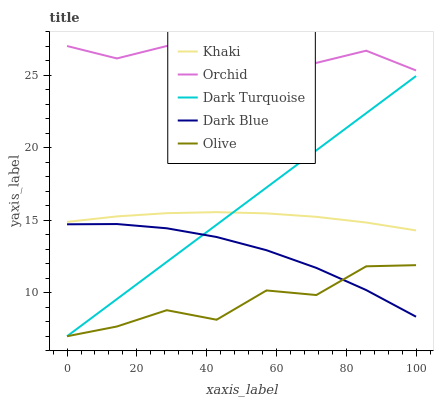Does Olive have the minimum area under the curve?
Answer yes or no. Yes. Does Orchid have the maximum area under the curve?
Answer yes or no. Yes. Does Dark Turquoise have the minimum area under the curve?
Answer yes or no. No. Does Dark Turquoise have the maximum area under the curve?
Answer yes or no. No. Is Dark Turquoise the smoothest?
Answer yes or no. Yes. Is Olive the roughest?
Answer yes or no. Yes. Is Khaki the smoothest?
Answer yes or no. No. Is Khaki the roughest?
Answer yes or no. No. Does Olive have the lowest value?
Answer yes or no. Yes. Does Khaki have the lowest value?
Answer yes or no. No. Does Orchid have the highest value?
Answer yes or no. Yes. Does Dark Turquoise have the highest value?
Answer yes or no. No. Is Dark Turquoise less than Orchid?
Answer yes or no. Yes. Is Orchid greater than Dark Blue?
Answer yes or no. Yes. Does Dark Turquoise intersect Olive?
Answer yes or no. Yes. Is Dark Turquoise less than Olive?
Answer yes or no. No. Is Dark Turquoise greater than Olive?
Answer yes or no. No. Does Dark Turquoise intersect Orchid?
Answer yes or no. No. 